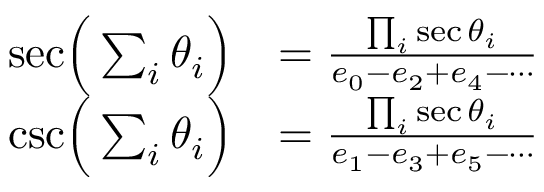<formula> <loc_0><loc_0><loc_500><loc_500>{ \begin{array} { r l } { { \sec } { \left ( } \sum _ { i } \theta _ { i } { \right ) } } & { = { \frac { \prod _ { i } \sec \theta _ { i } } { e _ { 0 } - e _ { 2 } + e _ { 4 } - \cdots } } } \\ { { \csc } { \left ( } \sum _ { i } \theta _ { i } { \right ) } } & { = { \frac { \prod _ { i } \sec \theta _ { i } } { e _ { 1 } - e _ { 3 } + e _ { 5 } - \cdots } } } \end{array} }</formula> 